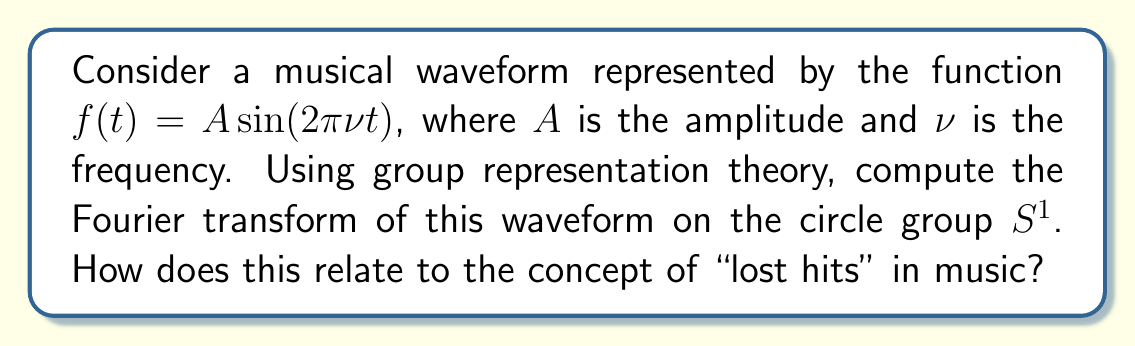Can you answer this question? Let's approach this step-by-step using group representation theory:

1) The circle group $S^1$ can be represented as the set of complex numbers with unit modulus: $\{e^{i\theta} : \theta \in [0, 2\pi)\}$.

2) The irreducible representations of $S^1$ are given by $\rho_n(e^{i\theta}) = e^{in\theta}$ for $n \in \mathbb{Z}$.

3) The Fourier transform on $S^1$ of a function $f$ is given by:

   $$\hat{f}(n) = \int_0^{2\pi} f(\theta) e^{-in\theta} \frac{d\theta}{2\pi}$$

4) In our case, $f(\theta) = A \sin(2\pi\nu \theta)$. We can rewrite this using Euler's formula:

   $$f(\theta) = \frac{A}{2i}(e^{2\pi i\nu \theta} - e^{-2\pi i\nu \theta})$$

5) Substituting this into the Fourier transform formula:

   $$\hat{f}(n) = \frac{A}{2i} \int_0^{2\pi} (e^{2\pi i\nu \theta} - e^{-2\pi i\nu \theta}) e^{-in\theta} \frac{d\theta}{2\pi}$$

6) This integral is nonzero only when $n = \pm 2\pi\nu$. Evaluating:

   $$\hat{f}(n) = \begin{cases}
   \frac{A}{2i}, & \text{if } n = 2\pi\nu \\
   -\frac{A}{2i}, & \text{if } n = -2\pi\nu \\
   0, & \text{otherwise}
   \end{cases}$$

7) This result shows that the Fourier transform of our sinusoidal waveform is concentrated at two specific frequencies, $\pm 2\pi\nu$.

Relating to "lost hits" in music: Just as a lost hit can be rediscovered and appreciated anew, the Fourier transform allows us to decompose a complex waveform into its fundamental frequencies. This process can reveal hidden harmonics or subtle musical elements that might have been overlooked in the original time-domain representation, much like rediscovering the nuances of a forgotten song.
Answer: $$\hat{f}(n) = \begin{cases}
\frac{A}{2i}, & \text{if } n = 2\pi\nu \\
-\frac{A}{2i}, & \text{if } n = -2\pi\nu \\
0, & \text{otherwise}
\end{cases}$$ 